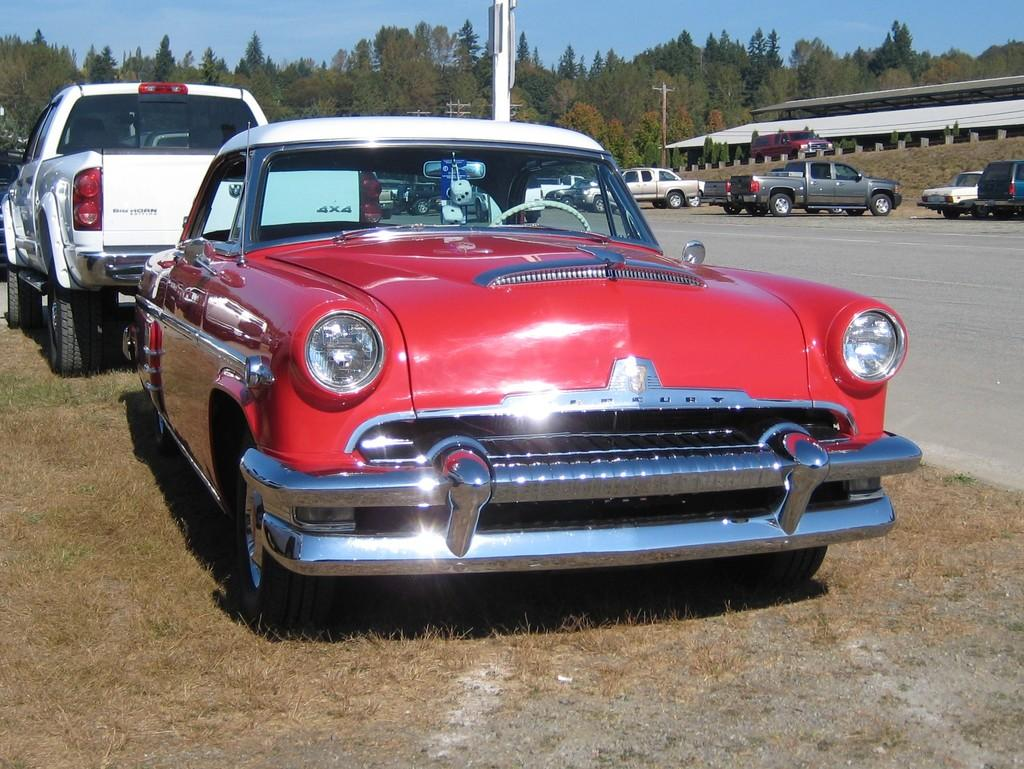What can be seen in large numbers in the image? There are many cars in the image. What is the primary surface visible in the image? There is a road visible in the image. What type of structure can be seen in the image? There is a shed in the image. What are the vertical structures in the image? There are poles in the image. What type of vegetation is present in the image? There are trees in the image, and dried grass can also be seen. What is visible at the top of the image? The sky is visible at the top of the image. What type of prose is being recited by the army on the sidewalk in the image? There is no army or sidewalk present in the image, and therefore no prose being recited. 